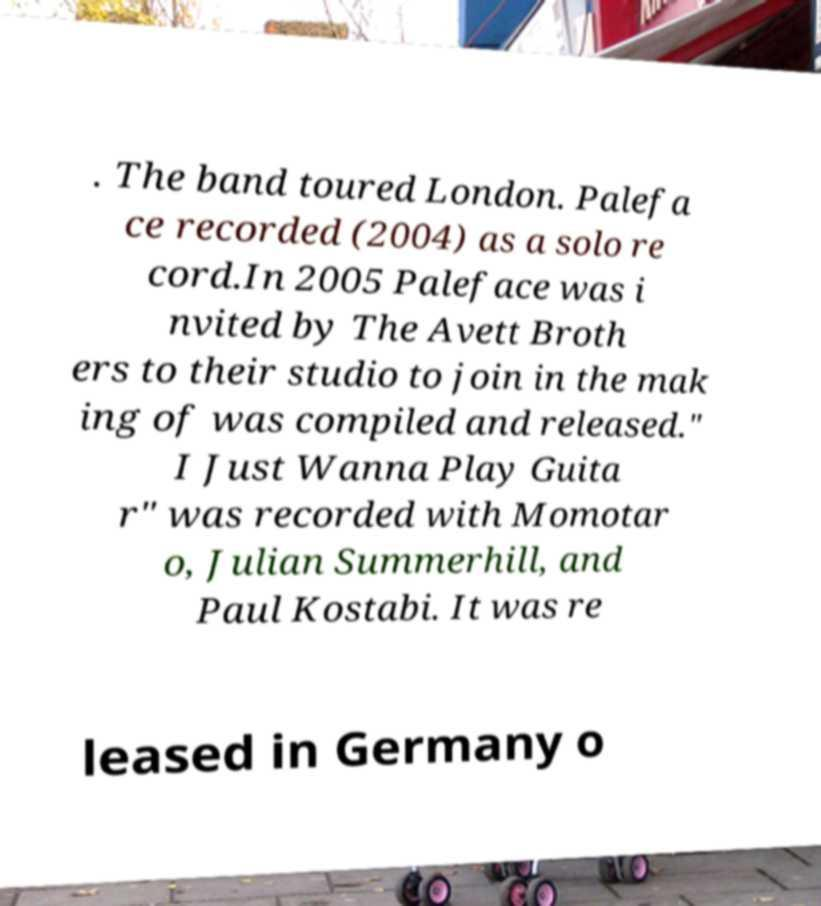There's text embedded in this image that I need extracted. Can you transcribe it verbatim? . The band toured London. Palefa ce recorded (2004) as a solo re cord.In 2005 Paleface was i nvited by The Avett Broth ers to their studio to join in the mak ing of was compiled and released." I Just Wanna Play Guita r" was recorded with Momotar o, Julian Summerhill, and Paul Kostabi. It was re leased in Germany o 